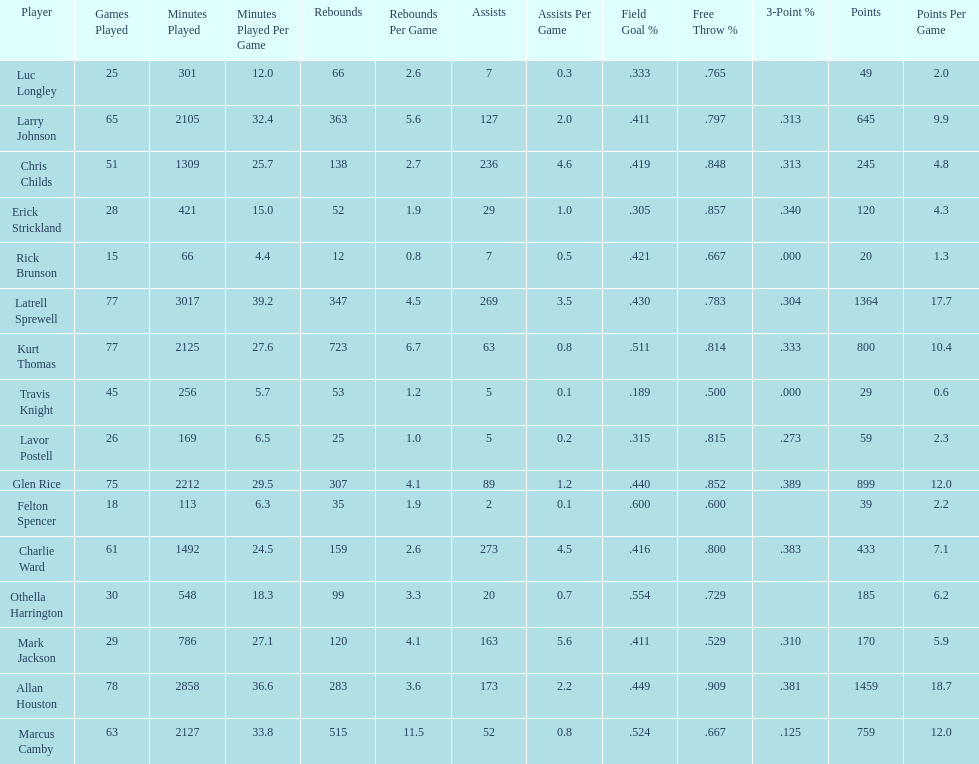Give the number of players covered by the table. 16. 